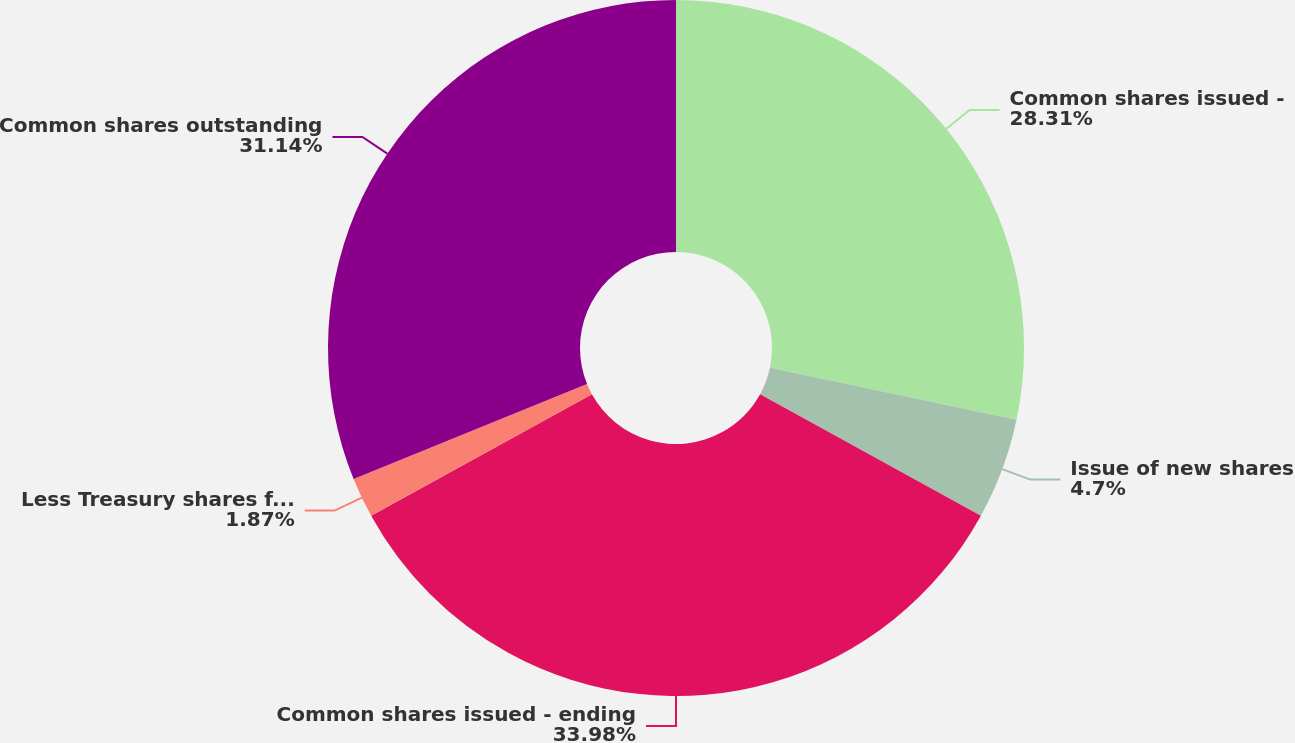Convert chart to OTSL. <chart><loc_0><loc_0><loc_500><loc_500><pie_chart><fcel>Common shares issued -<fcel>Issue of new shares<fcel>Common shares issued - ending<fcel>Less Treasury shares for which<fcel>Common shares outstanding<nl><fcel>28.31%<fcel>4.7%<fcel>33.98%<fcel>1.87%<fcel>31.14%<nl></chart> 